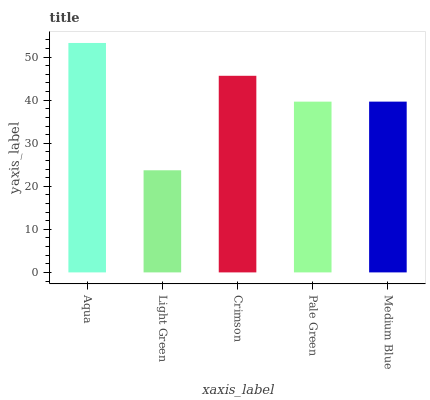Is Crimson the minimum?
Answer yes or no. No. Is Crimson the maximum?
Answer yes or no. No. Is Crimson greater than Light Green?
Answer yes or no. Yes. Is Light Green less than Crimson?
Answer yes or no. Yes. Is Light Green greater than Crimson?
Answer yes or no. No. Is Crimson less than Light Green?
Answer yes or no. No. Is Medium Blue the high median?
Answer yes or no. Yes. Is Medium Blue the low median?
Answer yes or no. Yes. Is Pale Green the high median?
Answer yes or no. No. Is Aqua the low median?
Answer yes or no. No. 